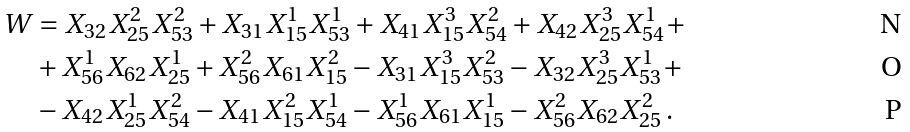<formula> <loc_0><loc_0><loc_500><loc_500>W & = X _ { 3 2 } X _ { 2 5 } ^ { 2 } X _ { 5 3 } ^ { 2 } + X _ { 3 1 } X _ { 1 5 } ^ { 1 } X _ { 5 3 } ^ { 1 } + X _ { 4 1 } X _ { 1 5 } ^ { 3 } X _ { 5 4 } ^ { 2 } + X _ { 4 2 } X _ { 2 5 } ^ { 3 } X _ { 5 4 } ^ { 1 } + \\ & + X _ { 5 6 } ^ { 1 } X _ { 6 2 } X _ { 2 5 } ^ { 1 } + X _ { 5 6 } ^ { 2 } X _ { 6 1 } X _ { 1 5 } ^ { 2 } - X _ { 3 1 } X _ { 1 5 } ^ { 3 } X _ { 5 3 } ^ { 2 } - X _ { 3 2 } X _ { 2 5 } ^ { 3 } X _ { 5 3 } ^ { 1 } + \\ & - X _ { 4 2 } X _ { 2 5 } ^ { 1 } X _ { 5 4 } ^ { 2 } - X _ { 4 1 } X _ { 1 5 } ^ { 2 } X _ { 5 4 } ^ { 1 } - X _ { 5 6 } ^ { 1 } X _ { 6 1 } X _ { 1 5 } ^ { 1 } - X _ { 5 6 } ^ { 2 } X _ { 6 2 } X _ { 2 5 } ^ { 2 } \, .</formula> 